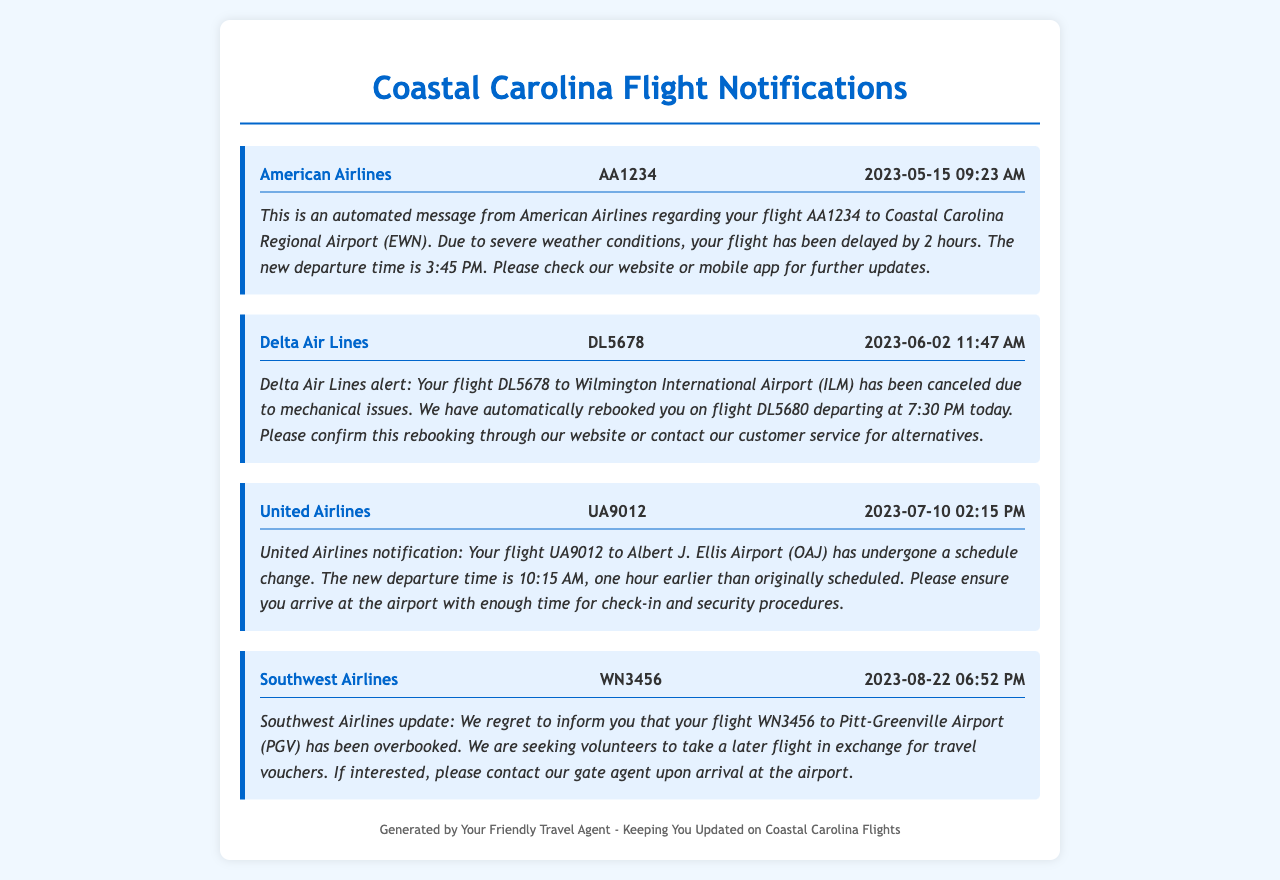What is the flight number for American Airlines? The flight number for American Airlines in the document is AA1234.
Answer: AA1234 What is the new departure time for flight DL5678? The new departure time for flight DL5678 is 7:30 PM.
Answer: 7:30 PM Which airport does United Airlines flight UA9012 go to? United Airlines flight UA9012 is going to Albert J. Ellis Airport (OAJ).
Answer: Albert J. Ellis Airport (OAJ) How long was American Airlines flight AA1234 delayed? American Airlines flight AA1234 was delayed by 2 hours.
Answer: 2 hours What action is Southwest Airlines requesting from passengers of flight WN3456? Southwest Airlines is seeking volunteers to take a later flight.
Answer: Seeking volunteers Which airline canceled flight DL5678? Delta Air Lines canceled flight DL5678.
Answer: Delta Air Lines What is the reason for the cancellation of flight DL5678? The reason for the cancellation of flight DL5678 is mechanical issues.
Answer: Mechanical issues What is the original scheduled departure time for United Airlines flight UA9012? The original scheduled departure time for United Airlines flight UA9012 was 11:15 AM.
Answer: 11:15 AM How many notifications are provided in this document? The document provides a total of 4 notifications.
Answer: 4 